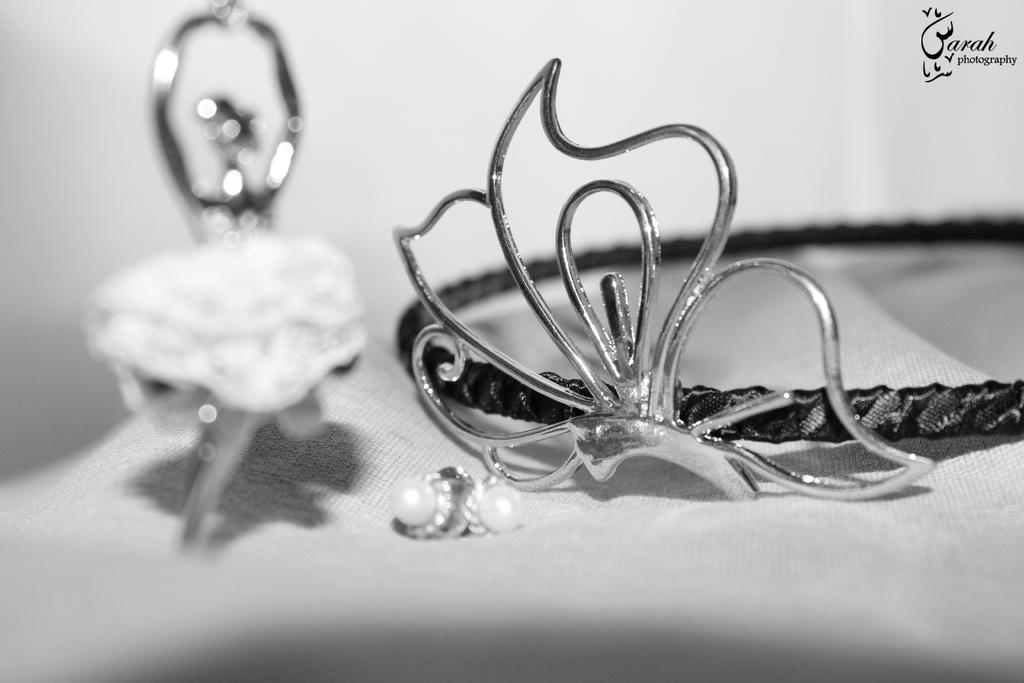What objects are present in the image? There are ornaments in the image. What is the color of the surface on which the ornaments are placed? The ornaments are on a white surface. Is there any additional information visible in the image? Yes, there is a watermark visible in the top right corner of the image. What type of measurements are listed on the ornaments in the image? There are no measurements listed on the ornaments in the image; they are simply decorative objects. Can you see a banana in the image? No, there is no banana present in the image. 